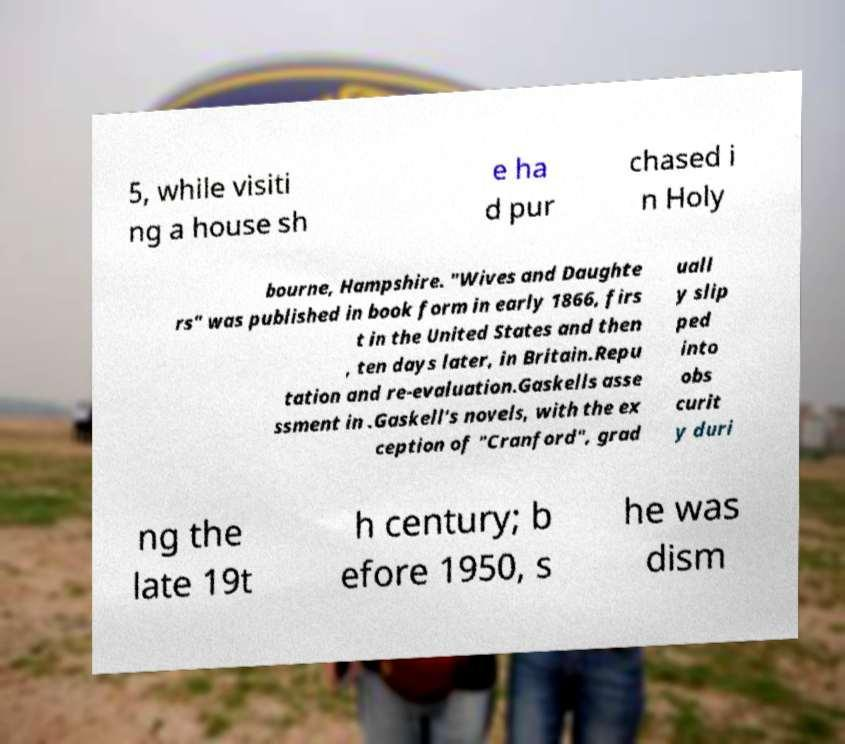Can you accurately transcribe the text from the provided image for me? 5, while visiti ng a house sh e ha d pur chased i n Holy bourne, Hampshire. "Wives and Daughte rs" was published in book form in early 1866, firs t in the United States and then , ten days later, in Britain.Repu tation and re-evaluation.Gaskells asse ssment in .Gaskell's novels, with the ex ception of "Cranford", grad uall y slip ped into obs curit y duri ng the late 19t h century; b efore 1950, s he was dism 